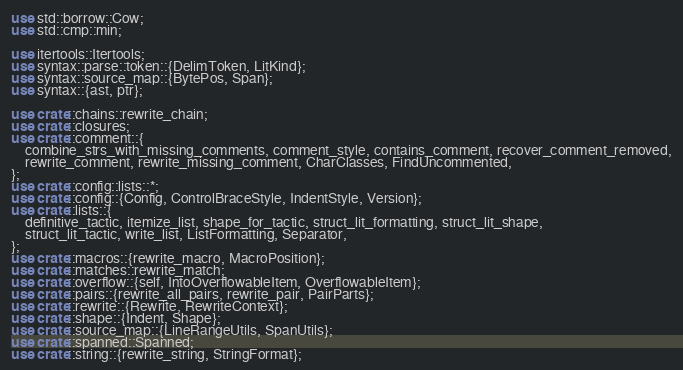<code> <loc_0><loc_0><loc_500><loc_500><_Rust_>use std::borrow::Cow;
use std::cmp::min;

use itertools::Itertools;
use syntax::parse::token::{DelimToken, LitKind};
use syntax::source_map::{BytePos, Span};
use syntax::{ast, ptr};

use crate::chains::rewrite_chain;
use crate::closures;
use crate::comment::{
    combine_strs_with_missing_comments, comment_style, contains_comment, recover_comment_removed,
    rewrite_comment, rewrite_missing_comment, CharClasses, FindUncommented,
};
use crate::config::lists::*;
use crate::config::{Config, ControlBraceStyle, IndentStyle, Version};
use crate::lists::{
    definitive_tactic, itemize_list, shape_for_tactic, struct_lit_formatting, struct_lit_shape,
    struct_lit_tactic, write_list, ListFormatting, Separator,
};
use crate::macros::{rewrite_macro, MacroPosition};
use crate::matches::rewrite_match;
use crate::overflow::{self, IntoOverflowableItem, OverflowableItem};
use crate::pairs::{rewrite_all_pairs, rewrite_pair, PairParts};
use crate::rewrite::{Rewrite, RewriteContext};
use crate::shape::{Indent, Shape};
use crate::source_map::{LineRangeUtils, SpanUtils};
use crate::spanned::Spanned;
use crate::string::{rewrite_string, StringFormat};</code> 